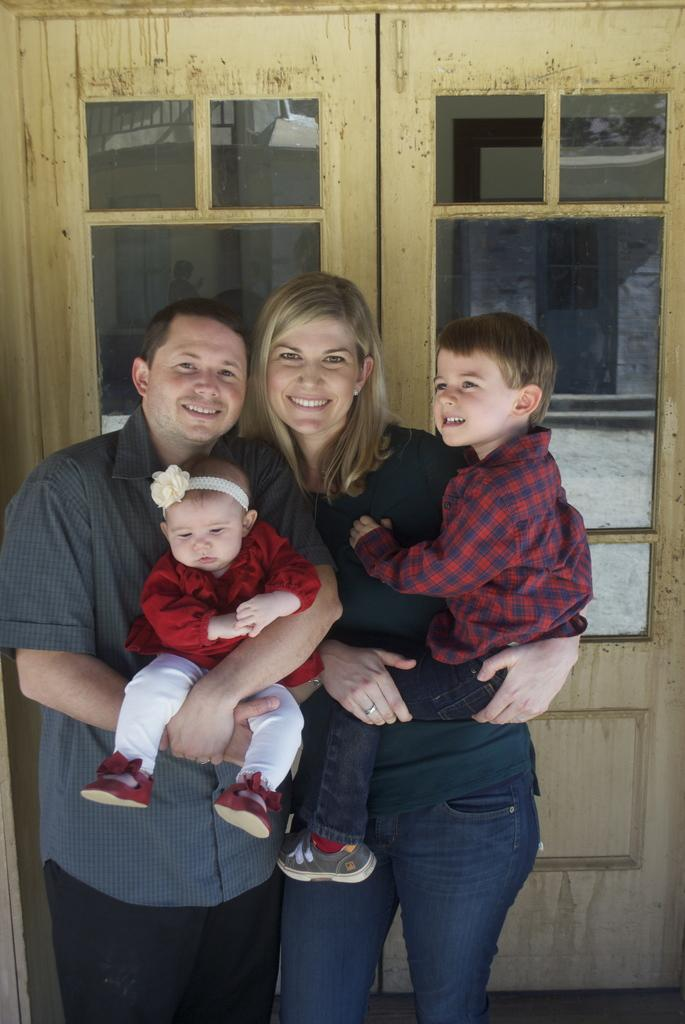How many people are present in the image? There are 2 people standing in the image. What are the people doing in the image? The people are carrying 2 children. Can you describe any architectural features in the image? Yes, there is a door visible in the image. How many mice can be seen playing with the children in the image? There are no mice present in the image. What type of bears are visible in the image? There are no bears present in the image. 